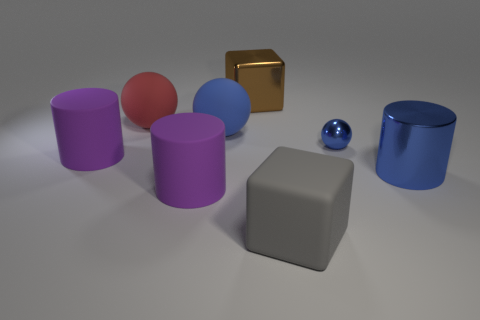There is a big cylinder to the right of the large gray matte cube; is there a big brown cube in front of it?
Your response must be concise. No. What is the material of the large red thing?
Ensure brevity in your answer.  Rubber. There is a big blue cylinder; are there any big metallic objects to the right of it?
Provide a short and direct response. No. What is the size of the red object that is the same shape as the large blue rubber object?
Offer a terse response. Large. Is the number of red spheres right of the large blue sphere the same as the number of large matte cylinders behind the gray rubber object?
Keep it short and to the point. No. How many cylinders are there?
Offer a terse response. 3. Are there more large gray things in front of the small metallic object than small brown rubber cylinders?
Give a very brief answer. Yes. What material is the block in front of the large brown object?
Offer a terse response. Rubber. What is the color of the other metallic object that is the same shape as the large gray thing?
Provide a succinct answer. Brown. How many matte objects are the same color as the tiny metallic sphere?
Your response must be concise. 1. 